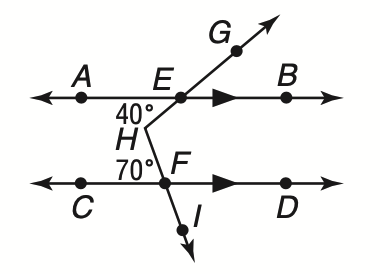Answer the mathemtical geometry problem and directly provide the correct option letter.
Question: What is the measure of \angle G H I?
Choices: A: 40 B: 70 C: 100 D: 110 D 